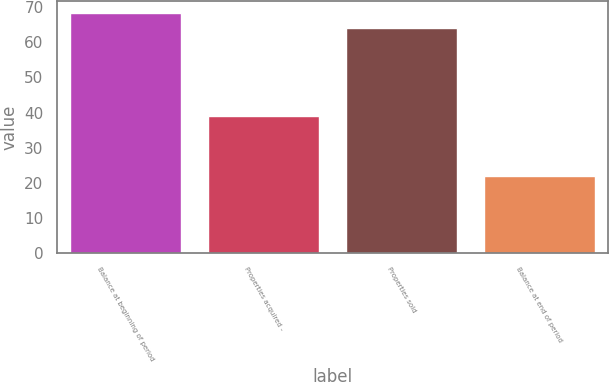Convert chart to OTSL. <chart><loc_0><loc_0><loc_500><loc_500><bar_chart><fcel>Balance at beginning of period<fcel>Properties acquired -<fcel>Properties sold<fcel>Balance at end of period<nl><fcel>68.3<fcel>39<fcel>64<fcel>22<nl></chart> 